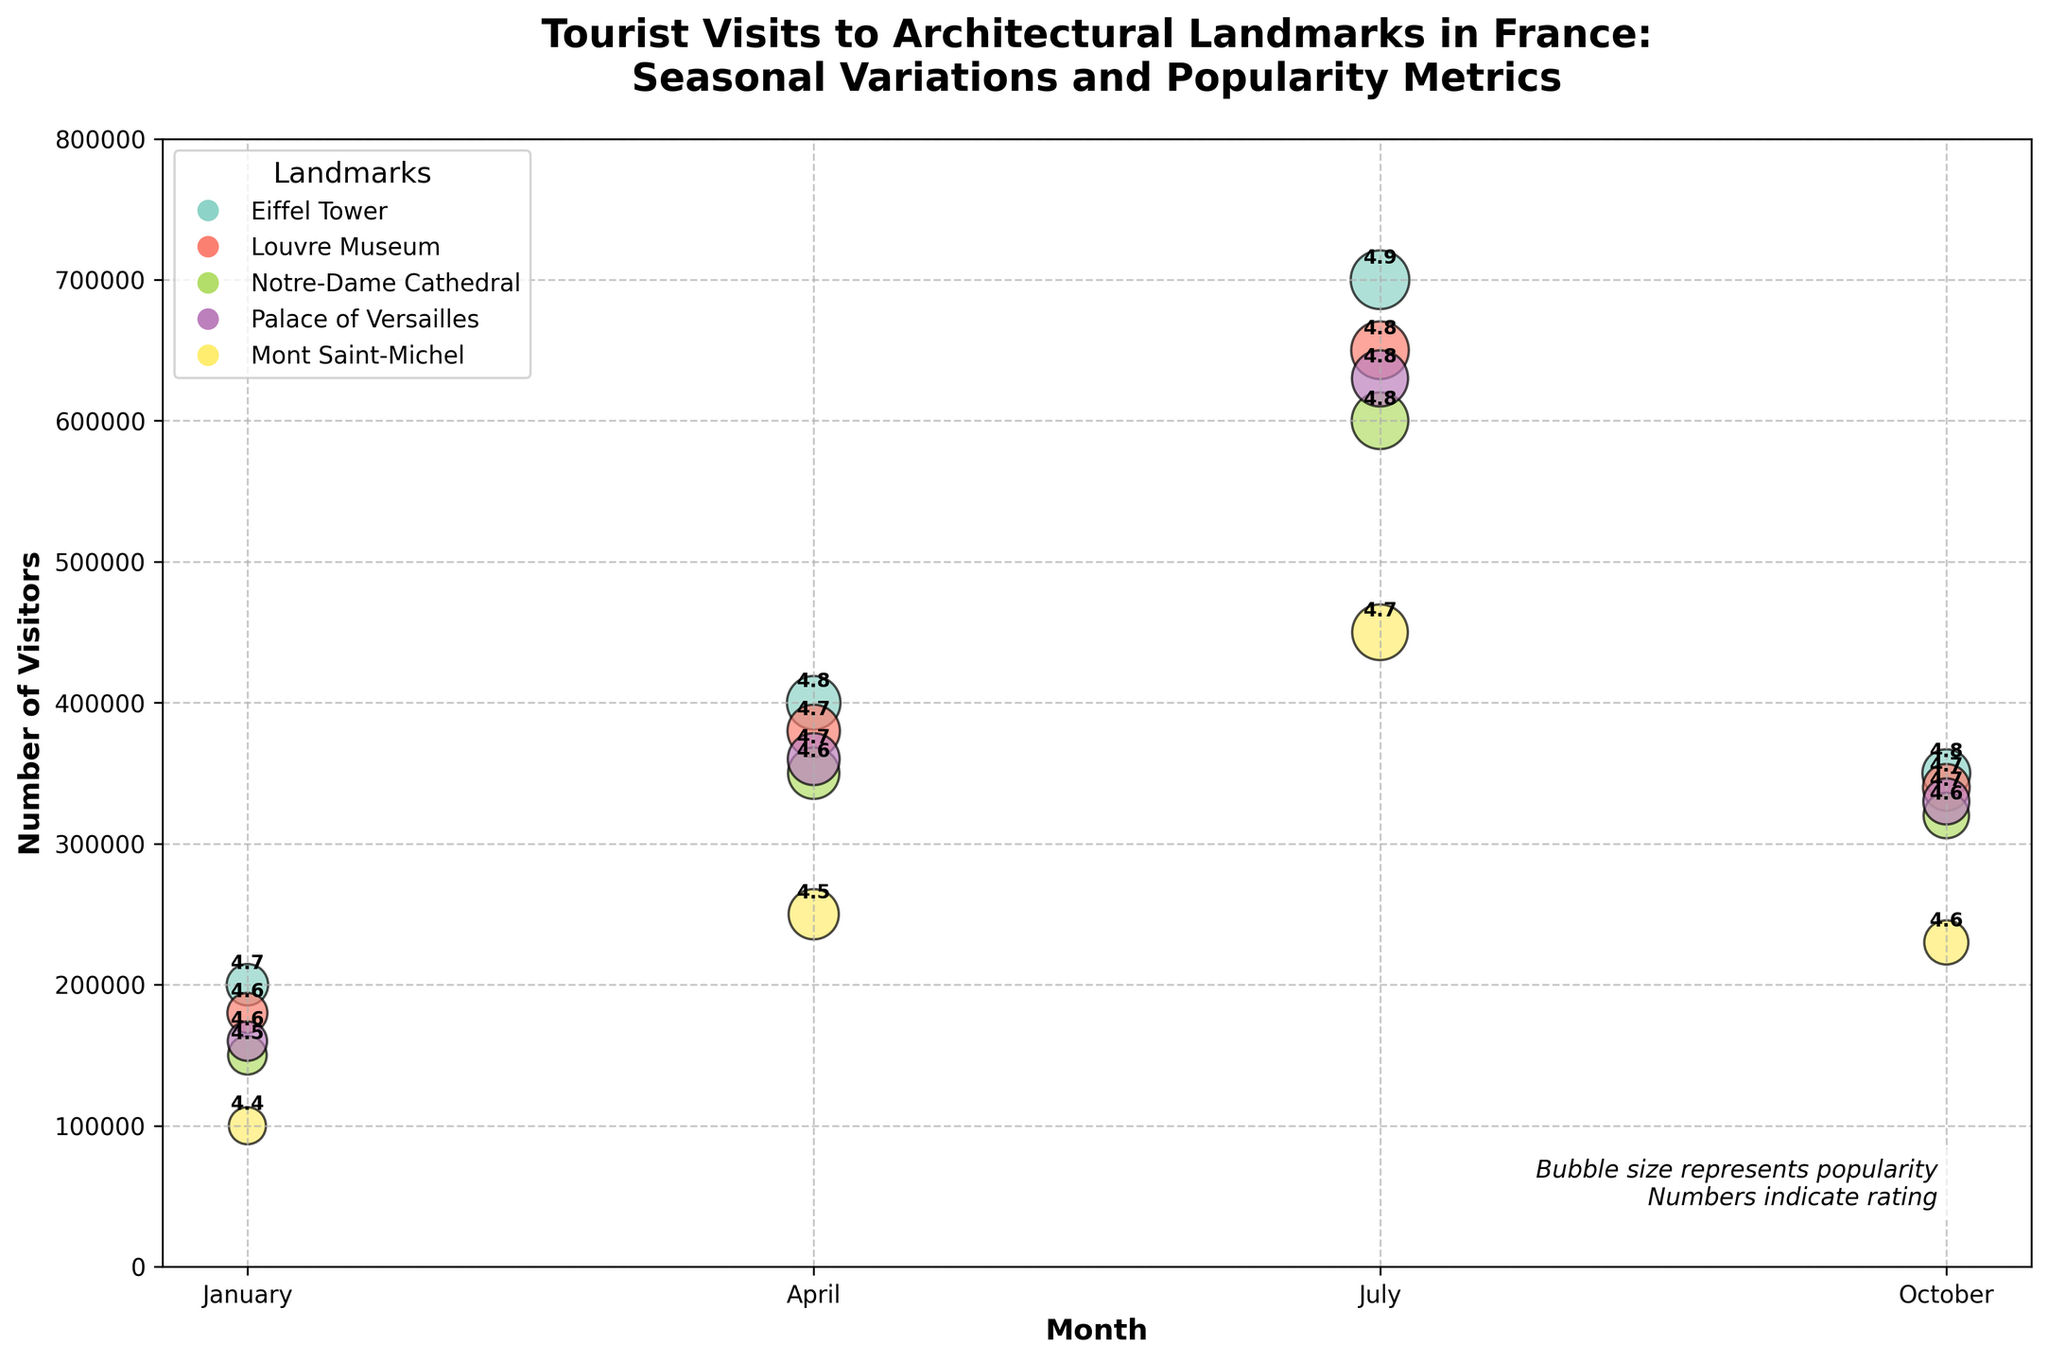What is the title of the figure? The title can be found at the top of the figure. It provides an overview of what the chart represents. The title reads: "Tourist Visits to Architectural Landmarks in France: Seasonal Variations and Popularity Metrics".
Answer: Tourist Visits to Architectural Landmarks in France: Seasonal Variations and Popularity Metrics How many landmarks are represented in the figure? By observing the legend, which indicates each unique landmark represented by different colors, we can count the number of distinct landmarks.
Answer: 5 Which landmark had the highest number of visitors in July? Look for the month of July on the x-axis, identify the highest data point among all the bubbles, and note the corresponding landmark by its color and label in the legend. The Eiffel Tower had 700,000 visitors in July.
Answer: Eiffel Tower What is the average rating of the Palace of Versailles across all months? Find the rating for the Palace of Versailles in each month and calculate the average. The ratings are 4.6, 4.7, 4.8, and 4.7. The average is (4.6 + 4.7 + 4.8 + 4.7) / 4.
Answer: 4.7 Which landmark has the smallest bubble size in January, and what does it represent? The smallest bubble size in January would represent the lowest popularity metric. By comparing the bubbles in January, Mont Saint-Michel has the smallest bubble size, indicating the lowest popularity.
Answer: Mont Saint-Michel, popularity metric How does the number of visitors to the Notre-Dame Cathedral change from January to July? Identify the data points for Notre-Dame Cathedral in January and July by their colors and month labels, then note the number of visitors. In January, it has 150,000 visitors, and in July, it has 600,000 visitors, showing an increase.
Answer: increases by 450,000 Which two landmarks have the most similar number of visitors in October? Compare the visitor numbers for each landmark in October. The Louvre Museum (340,000) and the Palace of Versailles (330,000) have the most similar visitor numbers.
Answer: Louvre Museum and Palace of Versailles What is the trend in the number of visitors to Mont Saint-Michel across the months shown? Observe the positioning of the bubbles for Mont Saint-Michel over the months: January, April, July, and October. The visitor numbers start at 100,000 in January, rise each month to 250,000 in April, peak at 450,000 in July, and then slightly drop to 230,000 in October.
Answer: rises and then falls 